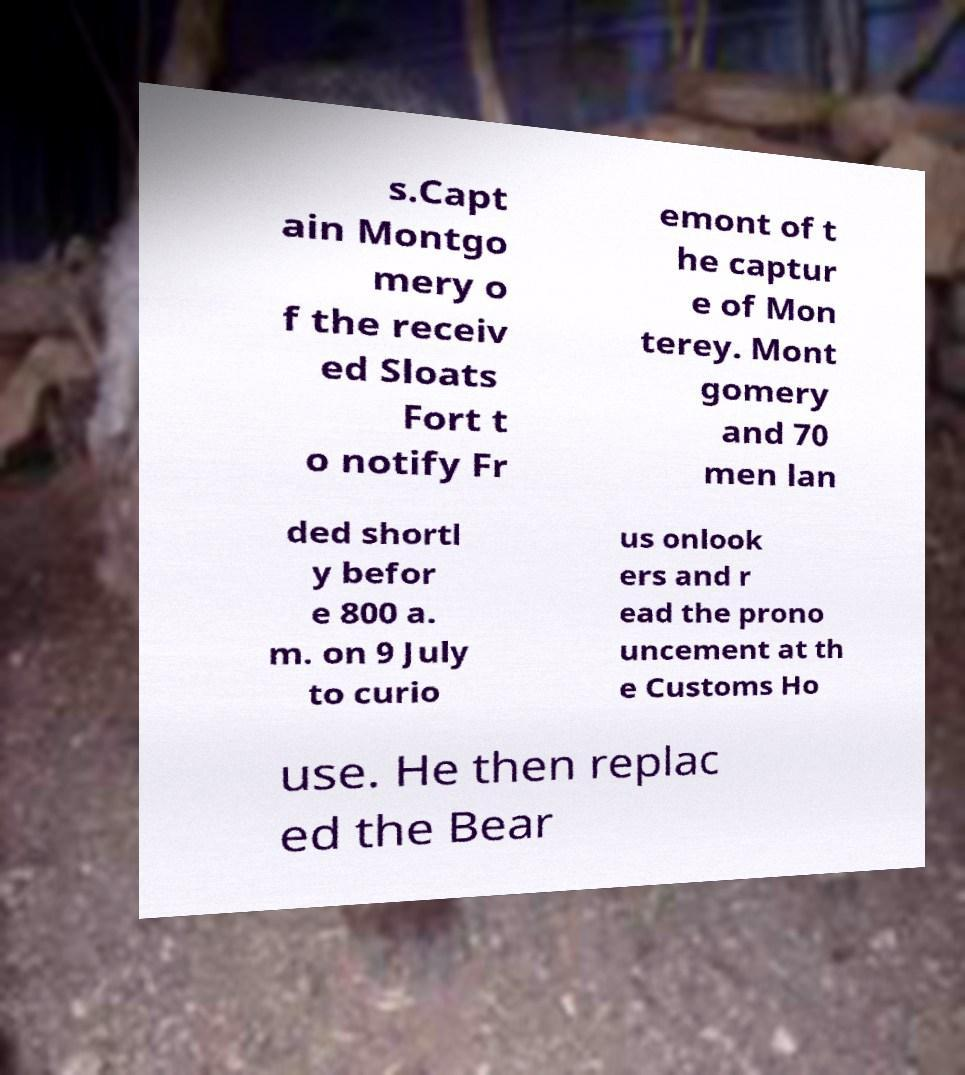Please read and relay the text visible in this image. What does it say? s.Capt ain Montgo mery o f the receiv ed Sloats Fort t o notify Fr emont of t he captur e of Mon terey. Mont gomery and 70 men lan ded shortl y befor e 800 a. m. on 9 July to curio us onlook ers and r ead the prono uncement at th e Customs Ho use. He then replac ed the Bear 